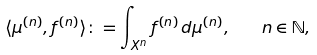Convert formula to latex. <formula><loc_0><loc_0><loc_500><loc_500>\langle \mu ^ { ( n ) } , f ^ { ( n ) } \rangle \colon = \int _ { X ^ { n } } f ^ { ( n ) } \, d \mu ^ { ( n ) } , \quad n \in \mathbb { N } ,</formula> 